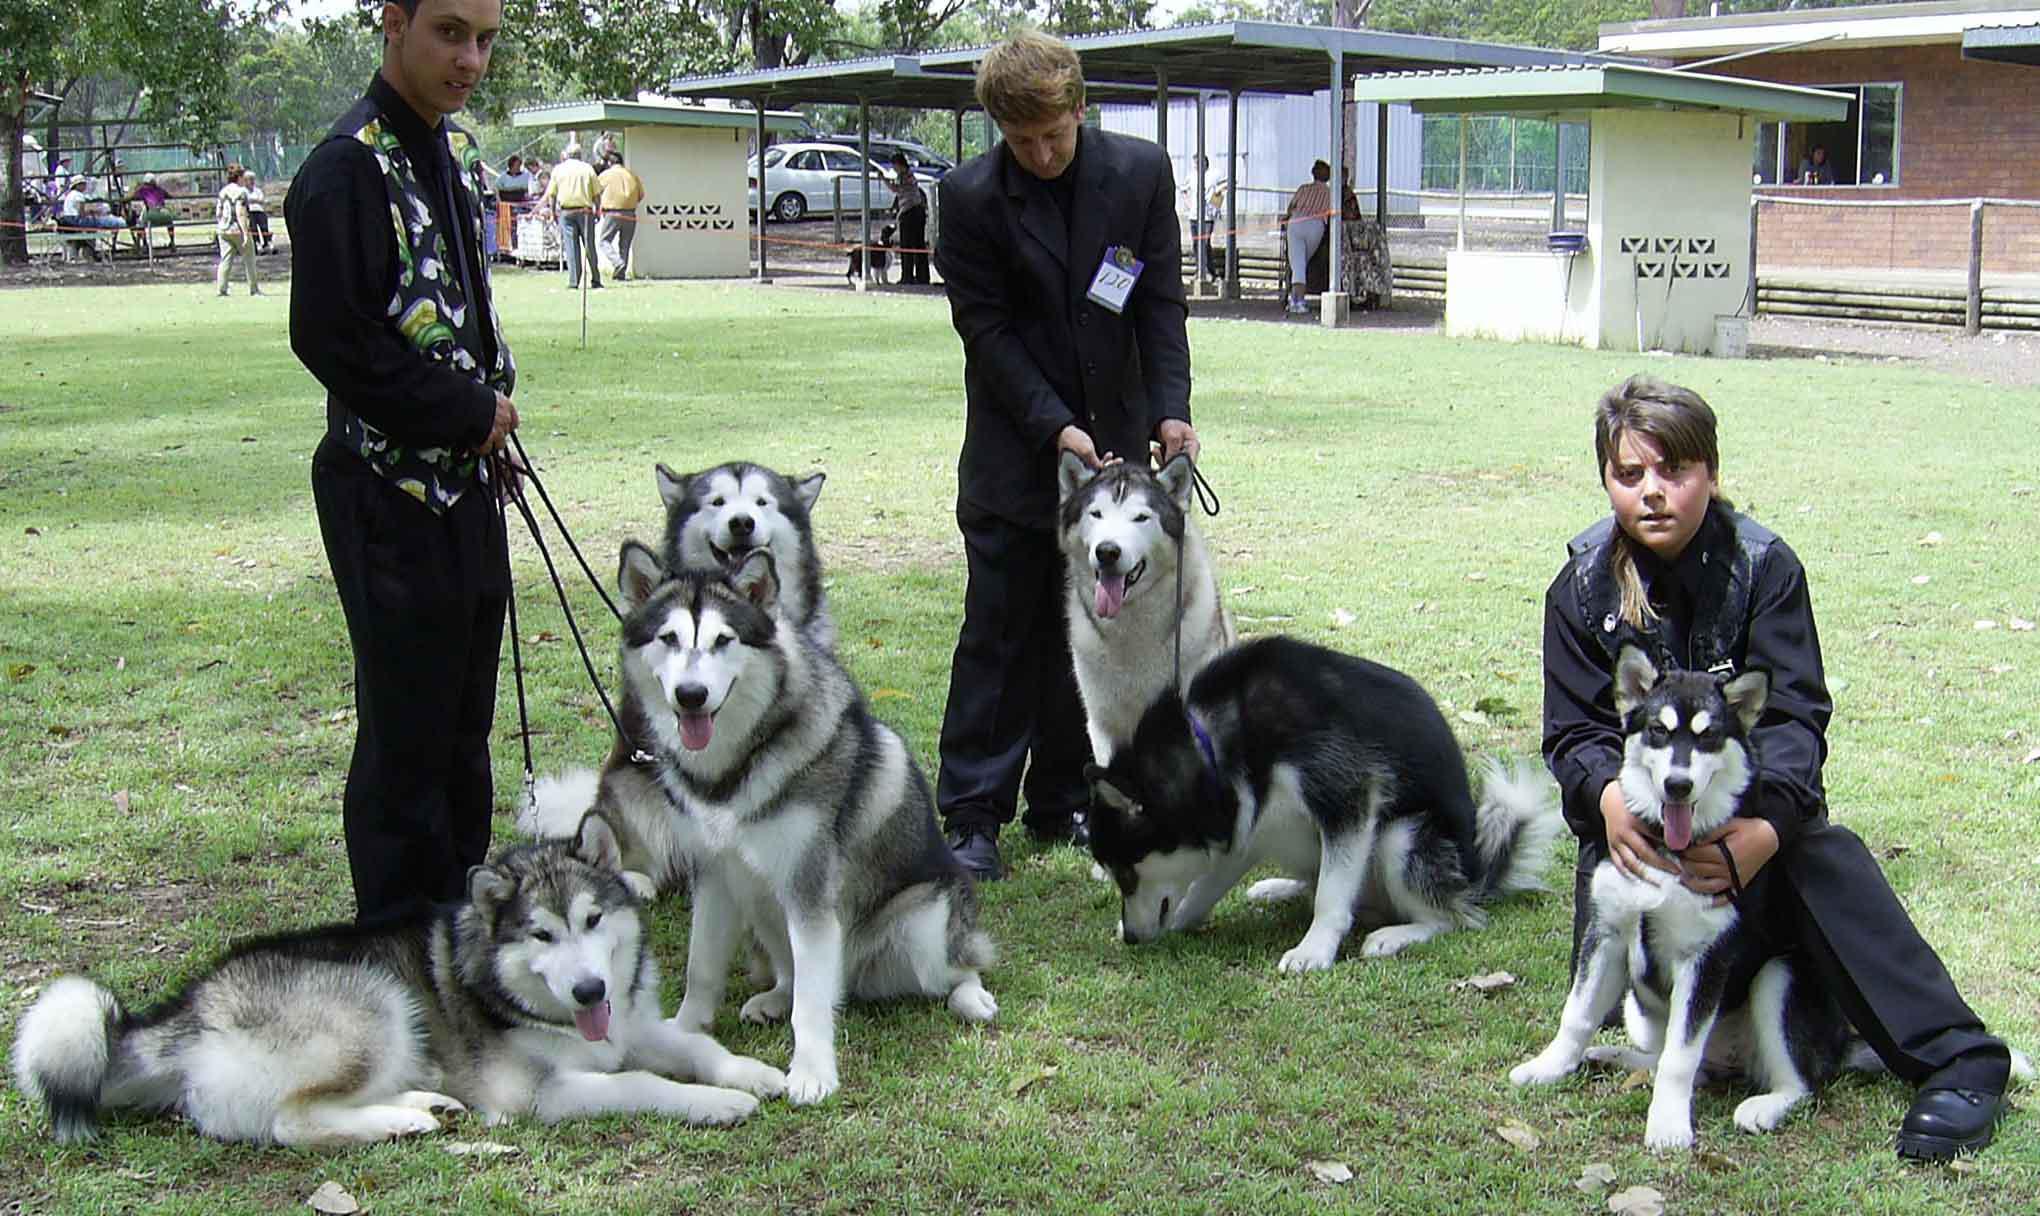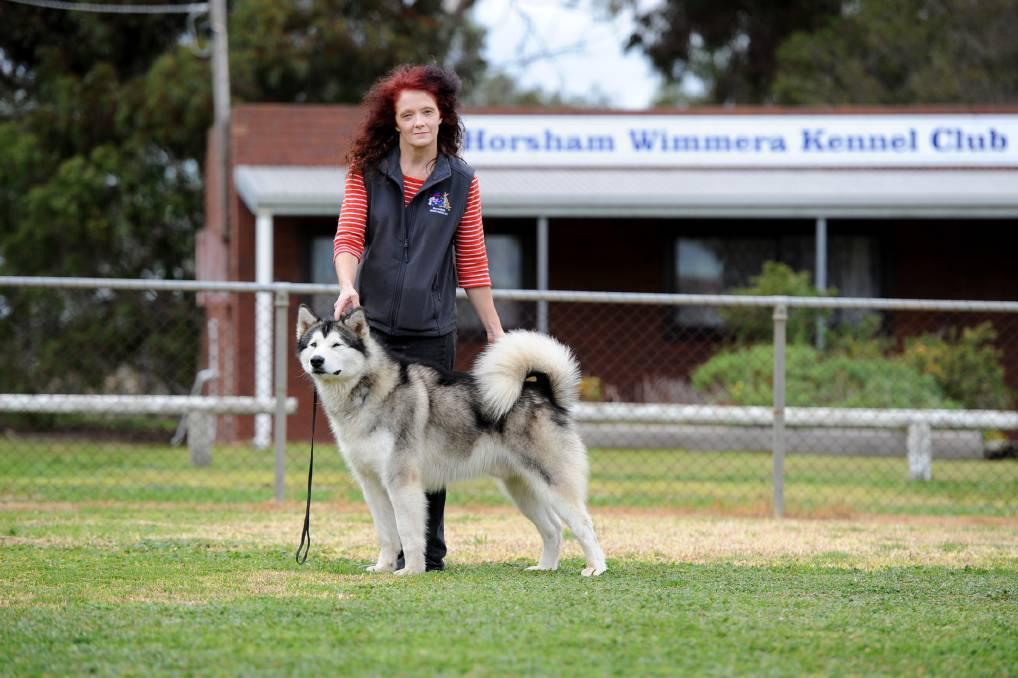The first image is the image on the left, the second image is the image on the right. Assess this claim about the two images: "The right image features one person standing behind a dog standing in profile, and the left image includes a person crouching behind a dog.". Correct or not? Answer yes or no. Yes. The first image is the image on the left, the second image is the image on the right. Assess this claim about the two images: "The left and right image contains the same number of huskies.". Correct or not? Answer yes or no. No. 